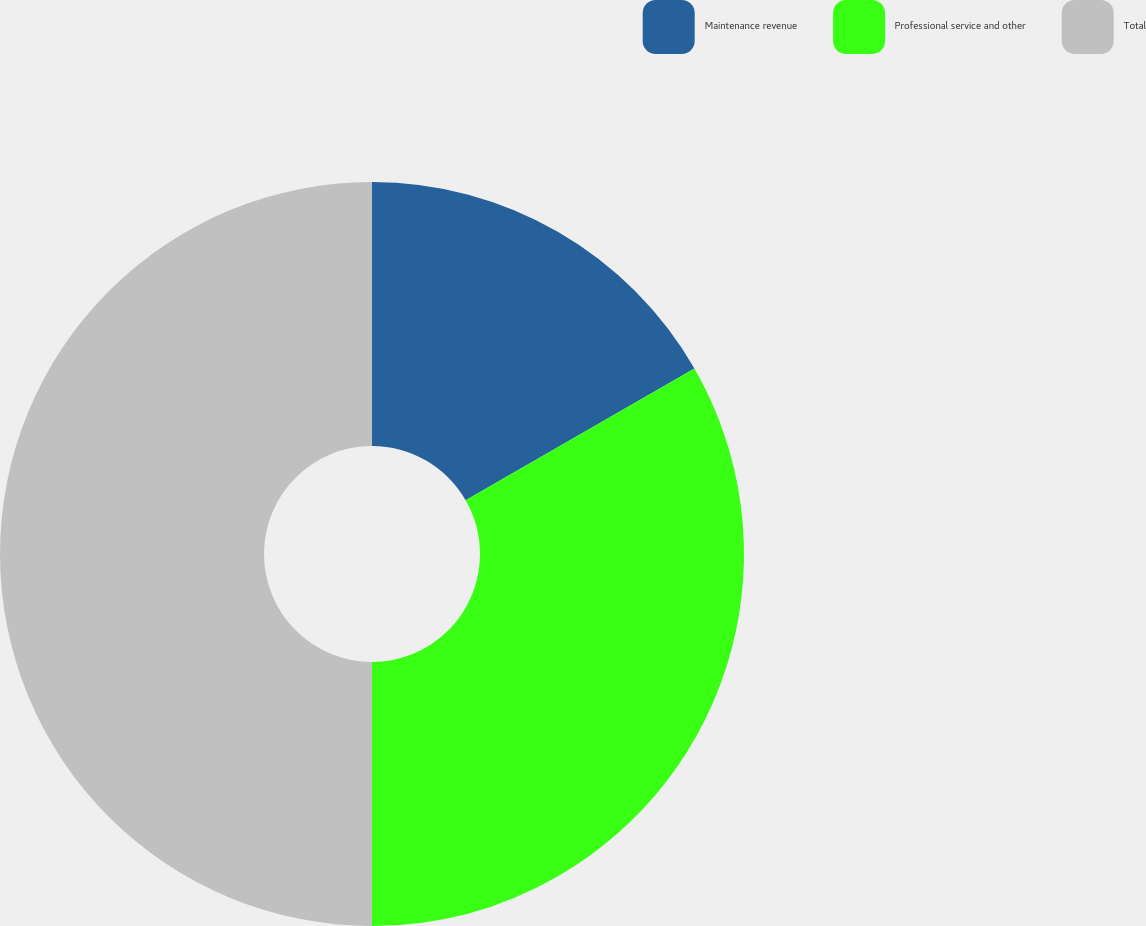Convert chart. <chart><loc_0><loc_0><loc_500><loc_500><pie_chart><fcel>Maintenance revenue<fcel>Professional service and other<fcel>Total<nl><fcel>16.69%<fcel>33.31%<fcel>50.0%<nl></chart> 